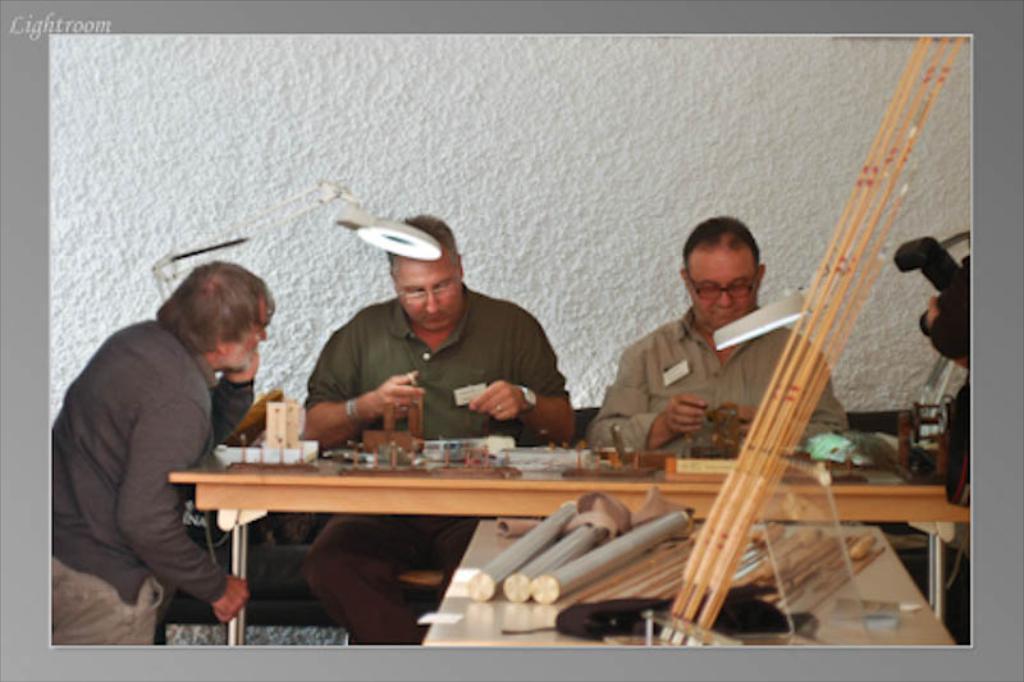In one or two sentences, can you explain what this image depicts? In the center of the image a table is there. On the table we can see some objects are present. In the middle of the image three persons are sitting. At the top of the image wall is there. On the left side of the image lamp is there. 